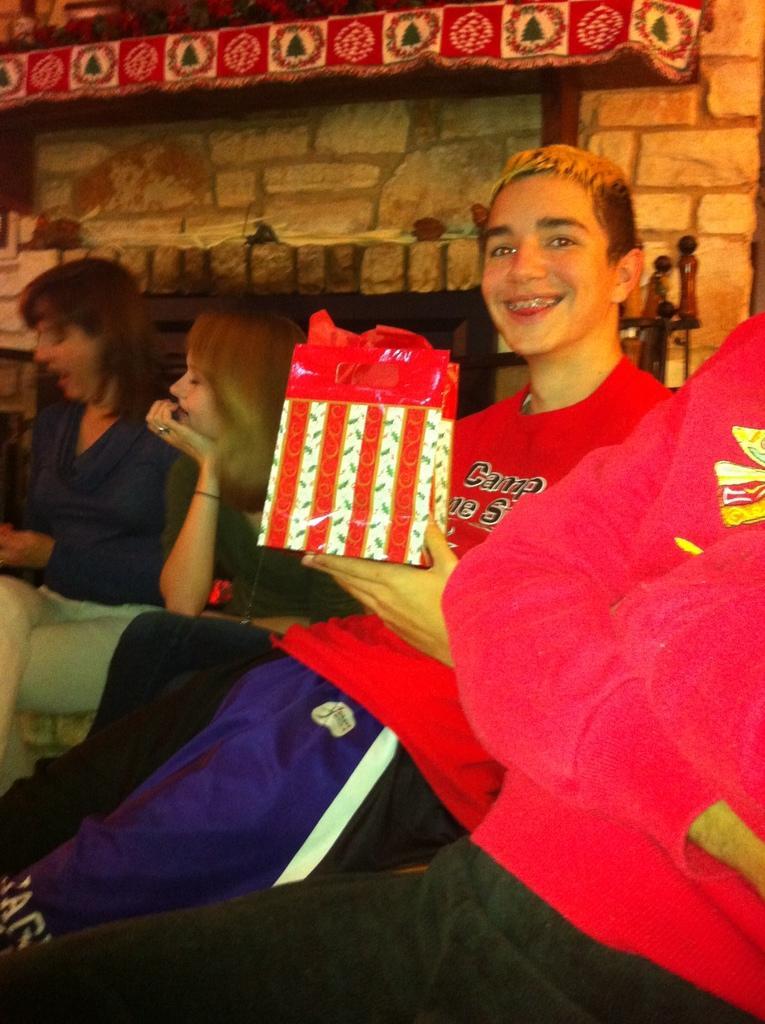How would you summarize this image in a sentence or two? In this image we can see these people are wearing red T-shirts and this person is holding a paper bag in his hands and smiling. Here we can see two women are also sitting here. In the background, we can see the stone wall. 